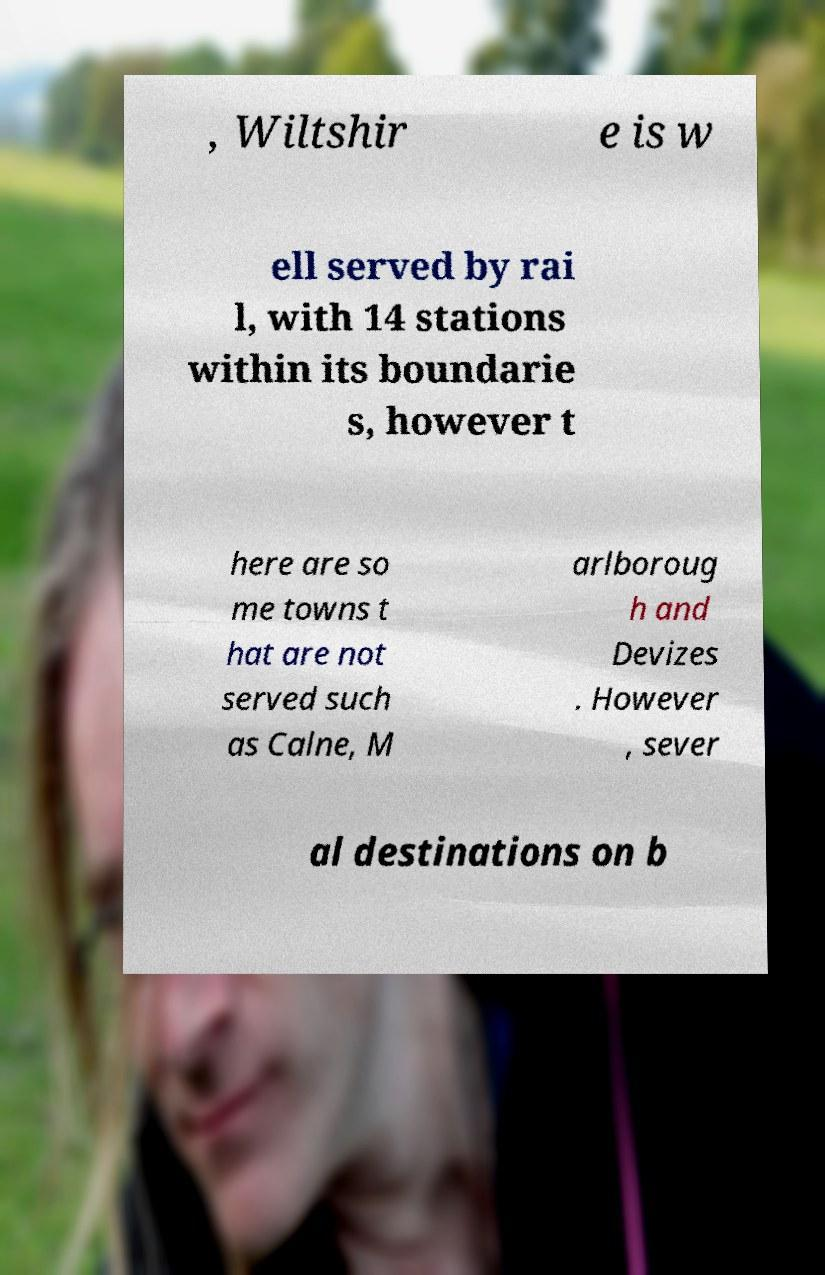Please identify and transcribe the text found in this image. , Wiltshir e is w ell served by rai l, with 14 stations within its boundarie s, however t here are so me towns t hat are not served such as Calne, M arlboroug h and Devizes . However , sever al destinations on b 